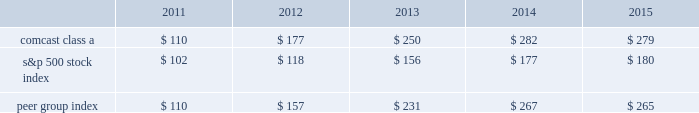Stock performance graph comcast the graph below compares the yearly percentage change in the cumulative total shareholder return on comcast 2019s class a common stock during the five years ended december 31 , 2015 with the cumulative total returns on the standard & poor 2019s 500 stock index and with a select peer group consisting of us and other companies engaged in the cable , communications and media industries .
This peer group consists of us , as well as cablevision systems corporation ( class a ) , dish network corporation ( class a ) , directv inc .
( included through july 24 , 2015 , the date of acquisition by at&t corp. ) and time warner cable inc .
( the 201ccable subgroup 201d ) , and time warner inc. , walt disney company , viacom inc .
( class b ) , twenty-first century fox , inc .
( class a ) , and cbs corporation ( class b ) ( the 201cmedia subgroup 201d ) .
The peer group was constructed as a composite peer group in which the cable subgroup is weighted 63% ( 63 % ) and the media subgroup is weighted 37% ( 37 % ) based on the respective revenue of our cable communications and nbcuniversal segments .
The graph assumes $ 100 was invested on december 31 , 2010 in our class a common stock and in each of the following indices and assumes the reinvestment of dividends .
Comparison of 5 year cumulative total return 12/1412/1312/1212/10 12/15 comcast class a s&p 500 peer group index .
Nbcuniversal nbcuniversal is a wholly owned subsidiary of nbcuniversal holdings and there is no market for its equity securities .
39 comcast 2015 annual report on form 10-k .
What was the differencet in percentage 5 year cumulative total return for comcast class a stock and the s&p 500 stock index for the year ended 2015? 
Computations: (((279 - 100) / 100) - ((180 - 100) / 100))
Answer: 0.99. 